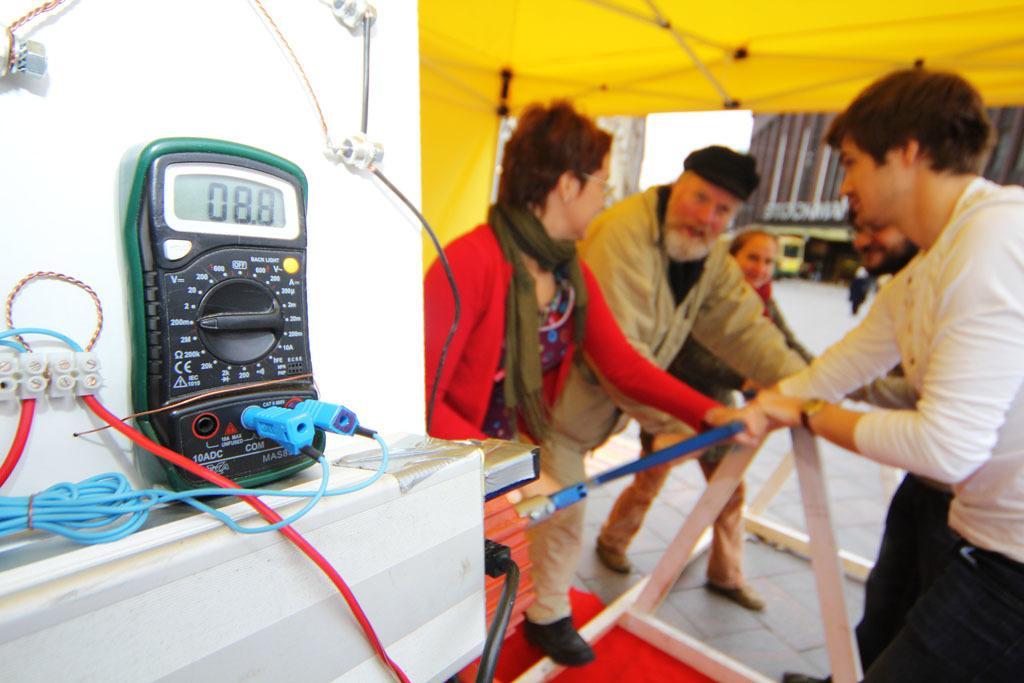Could you give a brief overview of what you see in this image? This picture describes about group of people, they are under the tent, and they are holding a metal rod, beside to them we can find a machine on the table, in the background we can find few buildings. 